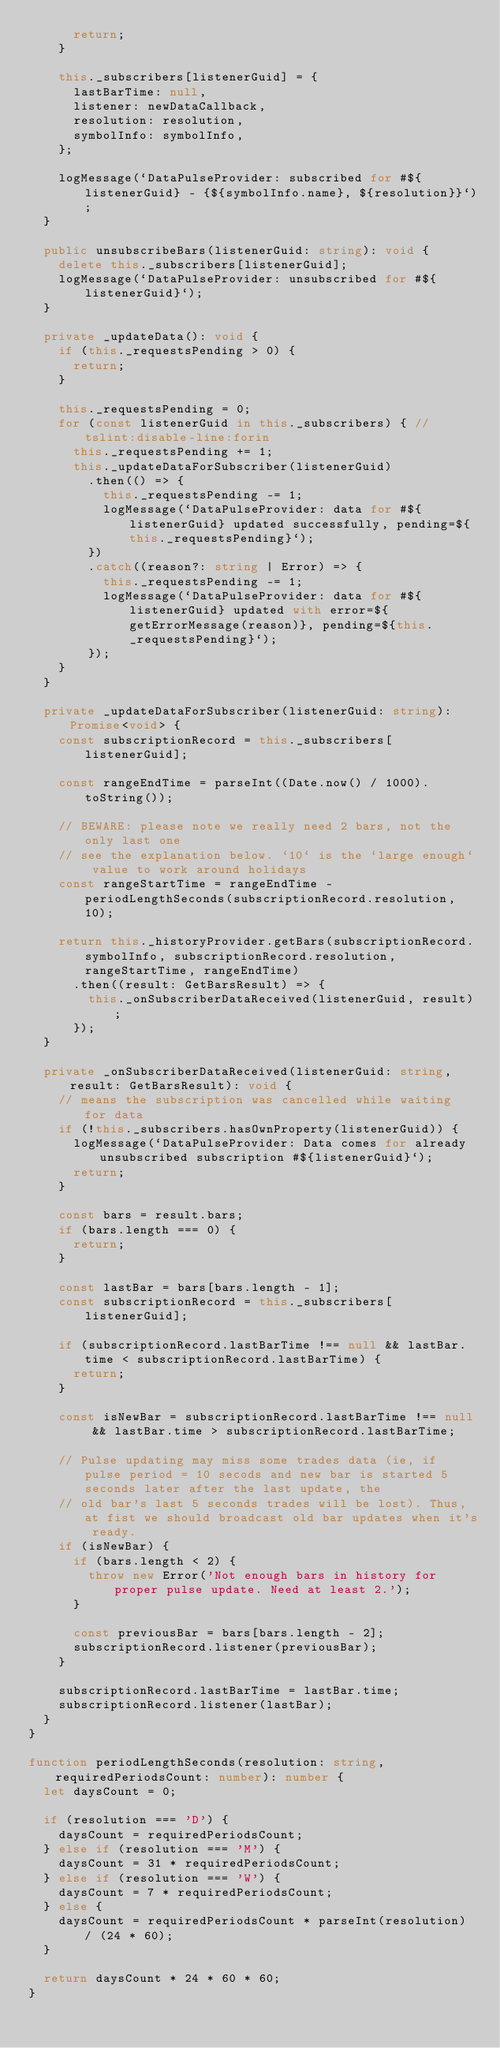Convert code to text. <code><loc_0><loc_0><loc_500><loc_500><_TypeScript_>			return;
		}

		this._subscribers[listenerGuid] = {
			lastBarTime: null,
			listener: newDataCallback,
			resolution: resolution,
			symbolInfo: symbolInfo,
		};

		logMessage(`DataPulseProvider: subscribed for #${listenerGuid} - {${symbolInfo.name}, ${resolution}}`);
	}

	public unsubscribeBars(listenerGuid: string): void {
		delete this._subscribers[listenerGuid];
		logMessage(`DataPulseProvider: unsubscribed for #${listenerGuid}`);
	}

	private _updateData(): void {
		if (this._requestsPending > 0) {
			return;
		}

		this._requestsPending = 0;
		for (const listenerGuid in this._subscribers) { // tslint:disable-line:forin
			this._requestsPending += 1;
			this._updateDataForSubscriber(listenerGuid)
				.then(() => {
					this._requestsPending -= 1;
					logMessage(`DataPulseProvider: data for #${listenerGuid} updated successfully, pending=${this._requestsPending}`);
				})
				.catch((reason?: string | Error) => {
					this._requestsPending -= 1;
					logMessage(`DataPulseProvider: data for #${listenerGuid} updated with error=${getErrorMessage(reason)}, pending=${this._requestsPending}`);
				});
		}
	}

	private _updateDataForSubscriber(listenerGuid: string): Promise<void> {
		const subscriptionRecord = this._subscribers[listenerGuid];

		const rangeEndTime = parseInt((Date.now() / 1000).toString());

		// BEWARE: please note we really need 2 bars, not the only last one
		// see the explanation below. `10` is the `large enough` value to work around holidays
		const rangeStartTime = rangeEndTime - periodLengthSeconds(subscriptionRecord.resolution, 10);

		return this._historyProvider.getBars(subscriptionRecord.symbolInfo, subscriptionRecord.resolution, rangeStartTime, rangeEndTime)
			.then((result: GetBarsResult) => {
				this._onSubscriberDataReceived(listenerGuid, result);
			});
	}

	private _onSubscriberDataReceived(listenerGuid: string, result: GetBarsResult): void {
		// means the subscription was cancelled while waiting for data
		if (!this._subscribers.hasOwnProperty(listenerGuid)) {
			logMessage(`DataPulseProvider: Data comes for already unsubscribed subscription #${listenerGuid}`);
			return;
		}

		const bars = result.bars;
		if (bars.length === 0) {
			return;
		}

		const lastBar = bars[bars.length - 1];
		const subscriptionRecord = this._subscribers[listenerGuid];

		if (subscriptionRecord.lastBarTime !== null && lastBar.time < subscriptionRecord.lastBarTime) {
			return;
		}

		const isNewBar = subscriptionRecord.lastBarTime !== null && lastBar.time > subscriptionRecord.lastBarTime;

		// Pulse updating may miss some trades data (ie, if pulse period = 10 secods and new bar is started 5 seconds later after the last update, the
		// old bar's last 5 seconds trades will be lost). Thus, at fist we should broadcast old bar updates when it's ready.
		if (isNewBar) {
			if (bars.length < 2) {
				throw new Error('Not enough bars in history for proper pulse update. Need at least 2.');
			}

			const previousBar = bars[bars.length - 2];
			subscriptionRecord.listener(previousBar);
		}

		subscriptionRecord.lastBarTime = lastBar.time;
		subscriptionRecord.listener(lastBar);
	}
}

function periodLengthSeconds(resolution: string, requiredPeriodsCount: number): number {
	let daysCount = 0;

	if (resolution === 'D') {
		daysCount = requiredPeriodsCount;
	} else if (resolution === 'M') {
		daysCount = 31 * requiredPeriodsCount;
	} else if (resolution === 'W') {
		daysCount = 7 * requiredPeriodsCount;
	} else {
		daysCount = requiredPeriodsCount * parseInt(resolution) / (24 * 60);
	}

	return daysCount * 24 * 60 * 60;
}
</code> 